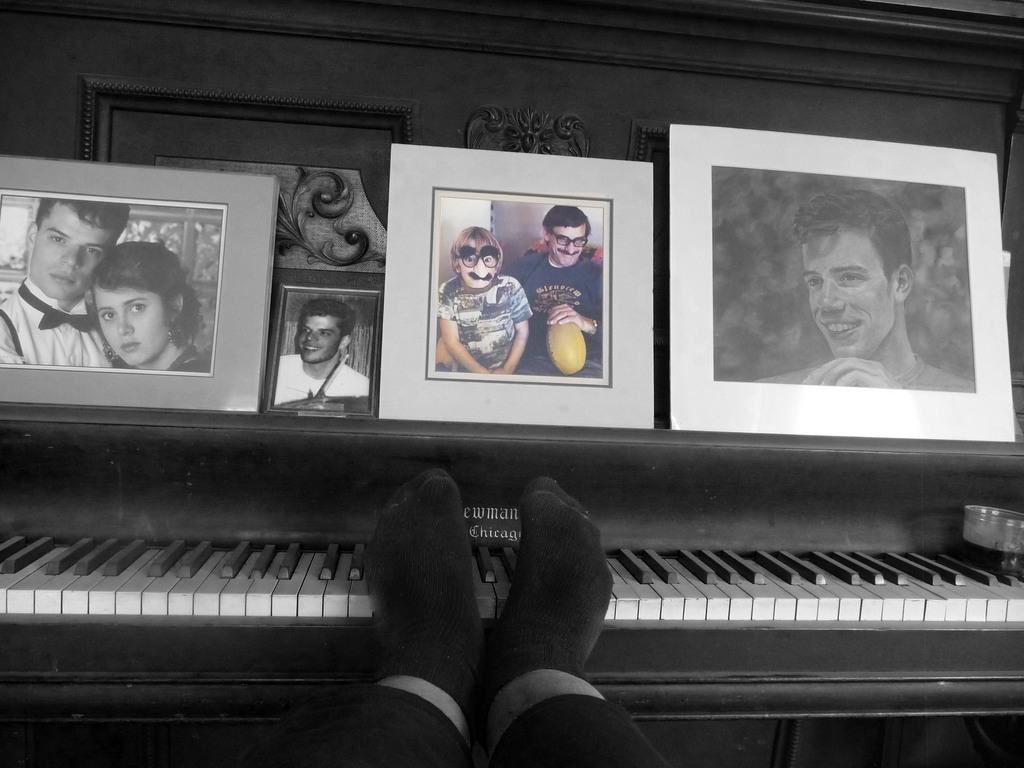Could you give a brief overview of what you see in this image? This is a picture of a white and black, there are the photo frames. The man is placing the legs on the piano and the piano has the black and white keys to play the music. 